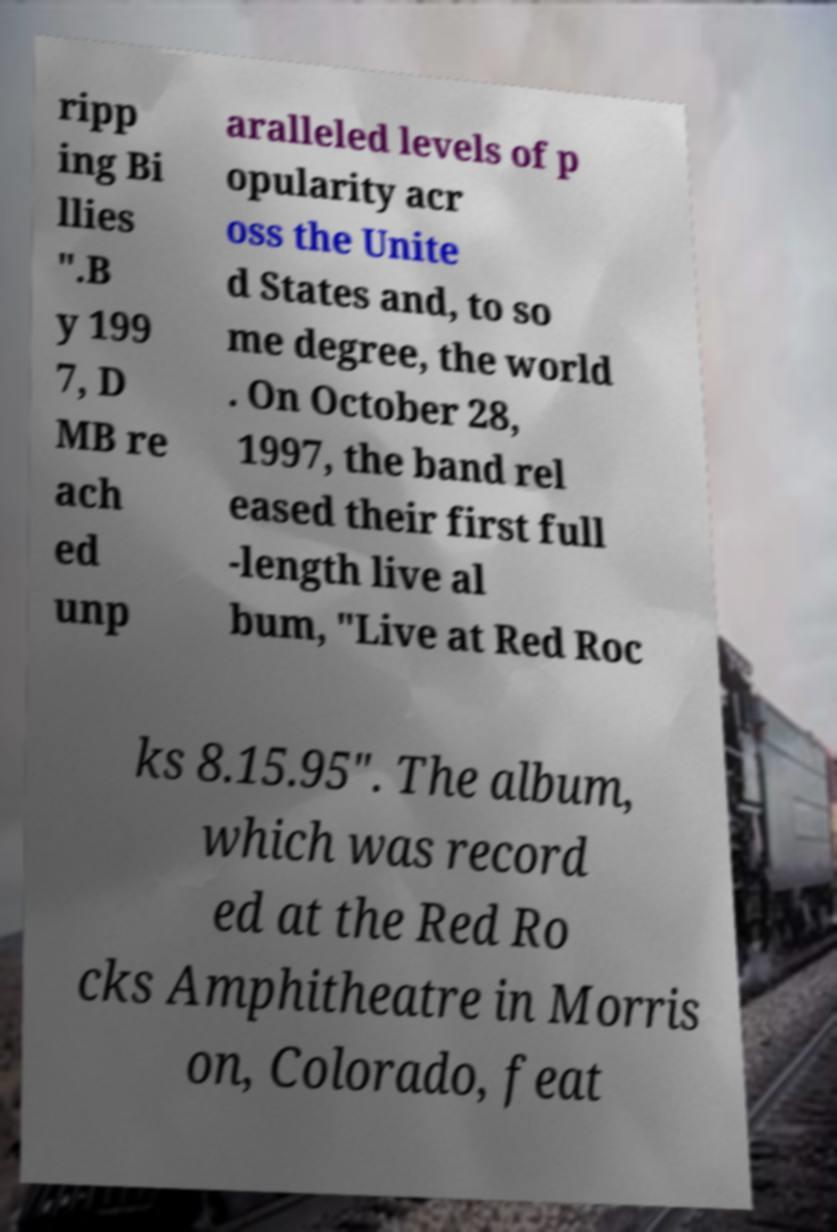For documentation purposes, I need the text within this image transcribed. Could you provide that? ripp ing Bi llies ".B y 199 7, D MB re ach ed unp aralleled levels of p opularity acr oss the Unite d States and, to so me degree, the world . On October 28, 1997, the band rel eased their first full -length live al bum, "Live at Red Roc ks 8.15.95". The album, which was record ed at the Red Ro cks Amphitheatre in Morris on, Colorado, feat 